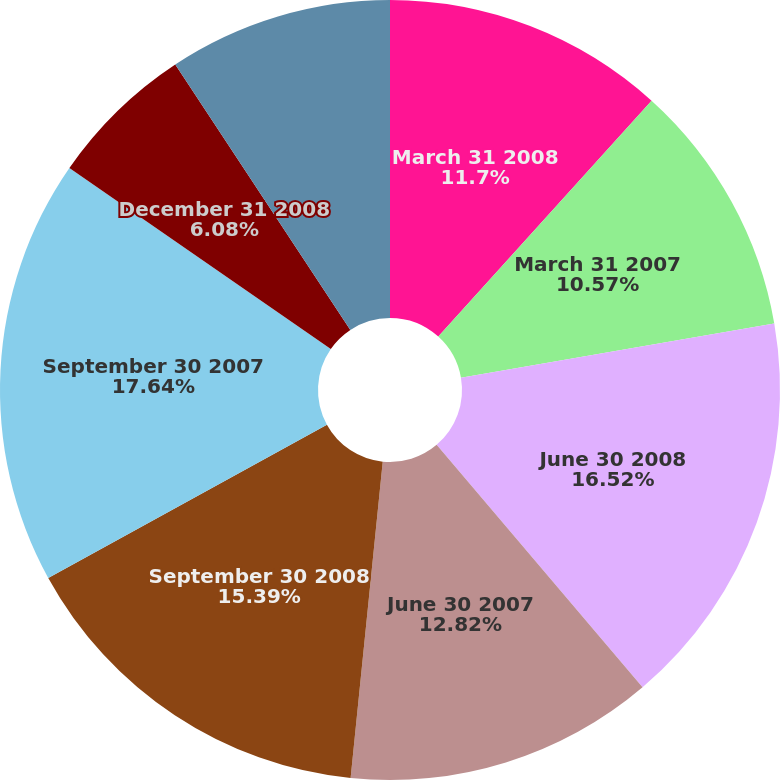Convert chart to OTSL. <chart><loc_0><loc_0><loc_500><loc_500><pie_chart><fcel>March 31 2008<fcel>March 31 2007<fcel>June 30 2008<fcel>June 30 2007<fcel>September 30 2008<fcel>September 30 2007<fcel>December 31 2008<fcel>December 31 2007<nl><fcel>11.7%<fcel>10.57%<fcel>16.52%<fcel>12.82%<fcel>15.39%<fcel>17.64%<fcel>6.08%<fcel>9.28%<nl></chart> 